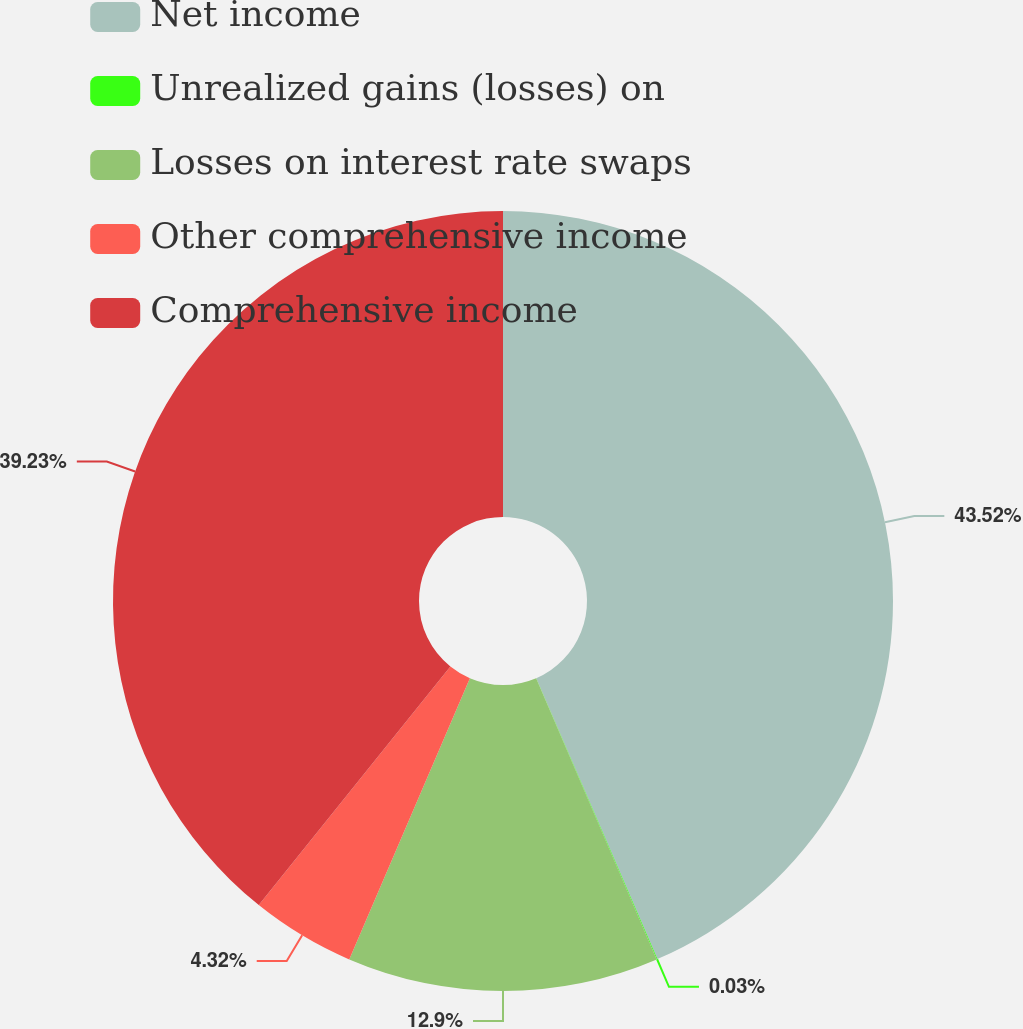<chart> <loc_0><loc_0><loc_500><loc_500><pie_chart><fcel>Net income<fcel>Unrealized gains (losses) on<fcel>Losses on interest rate swaps<fcel>Other comprehensive income<fcel>Comprehensive income<nl><fcel>43.52%<fcel>0.03%<fcel>12.9%<fcel>4.32%<fcel>39.23%<nl></chart> 